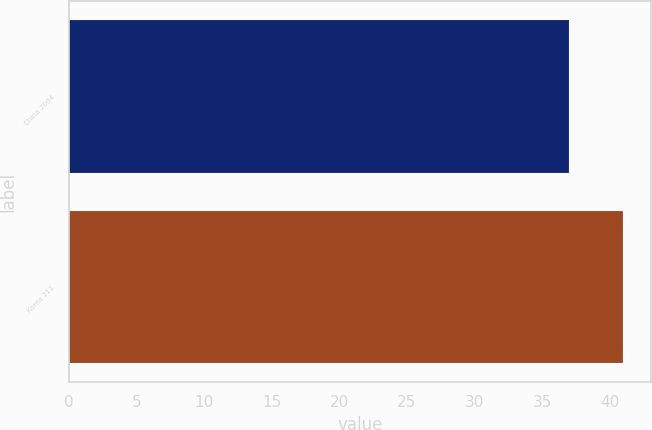<chart> <loc_0><loc_0><loc_500><loc_500><bar_chart><fcel>China 2004<fcel>Korea 211<nl><fcel>37<fcel>41<nl></chart> 